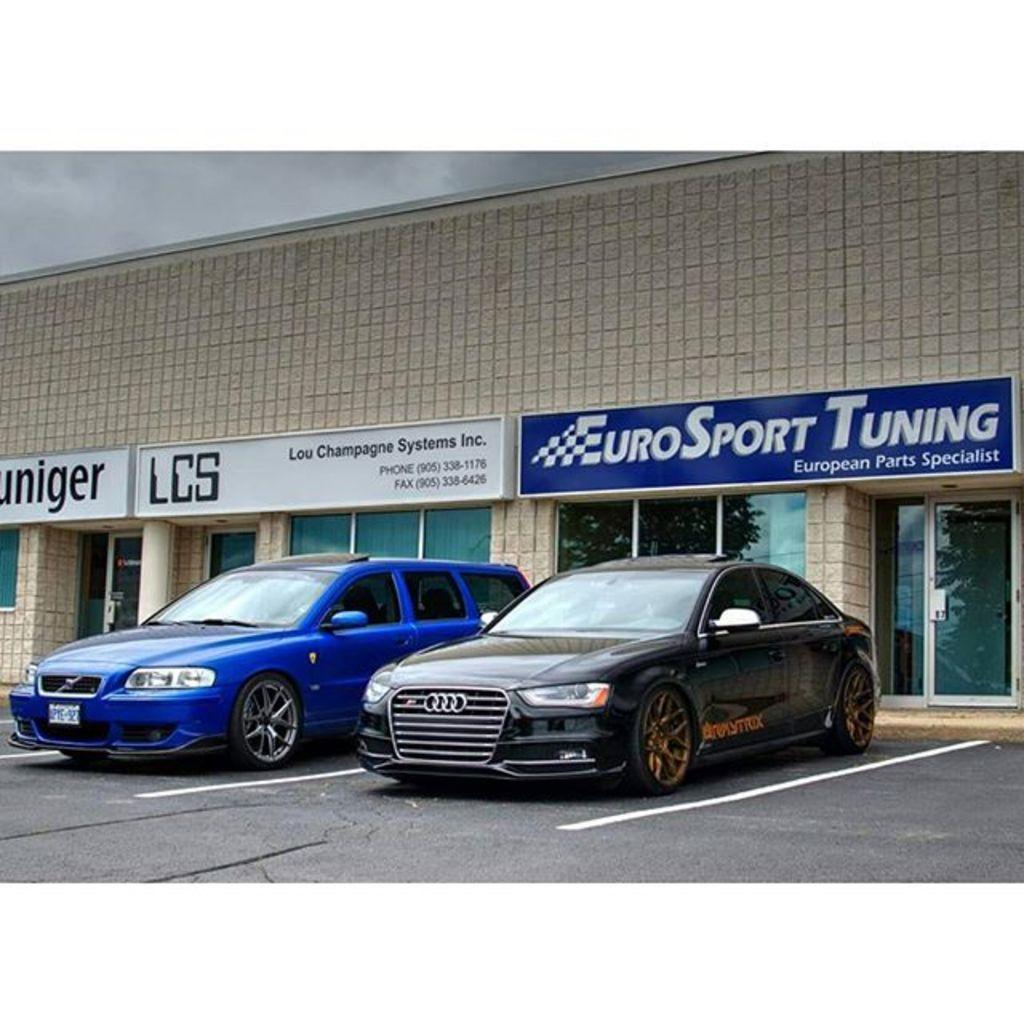Describe this image in one or two sentences. This picture shows couple of cars parked and we see a building and name boards on the wall and we see a cloudy sky. 